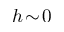Convert formula to latex. <formula><loc_0><loc_0><loc_500><loc_500>h \, \sim \, 0</formula> 